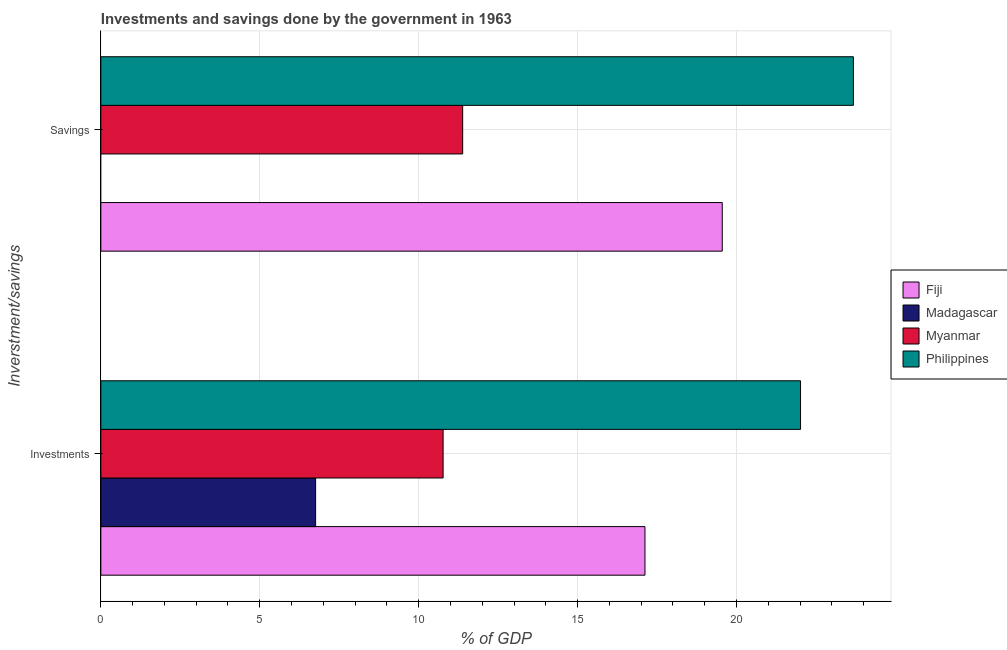How many different coloured bars are there?
Your response must be concise. 4. Are the number of bars on each tick of the Y-axis equal?
Provide a short and direct response. No. How many bars are there on the 2nd tick from the top?
Your answer should be very brief. 4. What is the label of the 2nd group of bars from the top?
Make the answer very short. Investments. What is the investments of government in Myanmar?
Offer a terse response. 10.77. Across all countries, what is the maximum investments of government?
Provide a short and direct response. 22.02. Across all countries, what is the minimum investments of government?
Your response must be concise. 6.76. What is the total investments of government in the graph?
Offer a very short reply. 56.66. What is the difference between the investments of government in Madagascar and that in Fiji?
Your answer should be very brief. -10.36. What is the difference between the savings of government in Madagascar and the investments of government in Philippines?
Offer a terse response. -22.02. What is the average investments of government per country?
Your answer should be very brief. 14.17. What is the difference between the investments of government and savings of government in Philippines?
Keep it short and to the point. -1.66. What is the ratio of the investments of government in Madagascar to that in Myanmar?
Keep it short and to the point. 0.63. Is the investments of government in Madagascar less than that in Myanmar?
Offer a very short reply. Yes. In how many countries, is the investments of government greater than the average investments of government taken over all countries?
Your response must be concise. 2. How many bars are there?
Offer a very short reply. 7. Are all the bars in the graph horizontal?
Ensure brevity in your answer.  Yes. How many countries are there in the graph?
Your response must be concise. 4. What is the difference between two consecutive major ticks on the X-axis?
Your answer should be very brief. 5. Does the graph contain grids?
Keep it short and to the point. Yes. Where does the legend appear in the graph?
Offer a terse response. Center right. How many legend labels are there?
Offer a terse response. 4. How are the legend labels stacked?
Keep it short and to the point. Vertical. What is the title of the graph?
Make the answer very short. Investments and savings done by the government in 1963. Does "Other small states" appear as one of the legend labels in the graph?
Keep it short and to the point. No. What is the label or title of the X-axis?
Ensure brevity in your answer.  % of GDP. What is the label or title of the Y-axis?
Your answer should be very brief. Inverstment/savings. What is the % of GDP of Fiji in Investments?
Keep it short and to the point. 17.12. What is the % of GDP in Madagascar in Investments?
Offer a very short reply. 6.76. What is the % of GDP of Myanmar in Investments?
Provide a short and direct response. 10.77. What is the % of GDP in Philippines in Investments?
Your answer should be very brief. 22.02. What is the % of GDP in Fiji in Savings?
Make the answer very short. 19.55. What is the % of GDP of Myanmar in Savings?
Your answer should be compact. 11.38. What is the % of GDP of Philippines in Savings?
Provide a succinct answer. 23.68. Across all Inverstment/savings, what is the maximum % of GDP in Fiji?
Offer a very short reply. 19.55. Across all Inverstment/savings, what is the maximum % of GDP in Madagascar?
Provide a succinct answer. 6.76. Across all Inverstment/savings, what is the maximum % of GDP of Myanmar?
Provide a short and direct response. 11.38. Across all Inverstment/savings, what is the maximum % of GDP in Philippines?
Your response must be concise. 23.68. Across all Inverstment/savings, what is the minimum % of GDP of Fiji?
Keep it short and to the point. 17.12. Across all Inverstment/savings, what is the minimum % of GDP in Myanmar?
Your answer should be very brief. 10.77. Across all Inverstment/savings, what is the minimum % of GDP of Philippines?
Offer a very short reply. 22.02. What is the total % of GDP of Fiji in the graph?
Your answer should be very brief. 36.67. What is the total % of GDP in Madagascar in the graph?
Provide a succinct answer. 6.76. What is the total % of GDP of Myanmar in the graph?
Ensure brevity in your answer.  22.15. What is the total % of GDP of Philippines in the graph?
Ensure brevity in your answer.  45.69. What is the difference between the % of GDP in Fiji in Investments and that in Savings?
Give a very brief answer. -2.43. What is the difference between the % of GDP in Myanmar in Investments and that in Savings?
Make the answer very short. -0.62. What is the difference between the % of GDP in Philippines in Investments and that in Savings?
Your response must be concise. -1.66. What is the difference between the % of GDP in Fiji in Investments and the % of GDP in Myanmar in Savings?
Provide a short and direct response. 5.74. What is the difference between the % of GDP in Fiji in Investments and the % of GDP in Philippines in Savings?
Give a very brief answer. -6.56. What is the difference between the % of GDP of Madagascar in Investments and the % of GDP of Myanmar in Savings?
Provide a short and direct response. -4.63. What is the difference between the % of GDP of Madagascar in Investments and the % of GDP of Philippines in Savings?
Your answer should be compact. -16.92. What is the difference between the % of GDP in Myanmar in Investments and the % of GDP in Philippines in Savings?
Your response must be concise. -12.91. What is the average % of GDP of Fiji per Inverstment/savings?
Offer a terse response. 18.34. What is the average % of GDP of Madagascar per Inverstment/savings?
Your answer should be compact. 3.38. What is the average % of GDP of Myanmar per Inverstment/savings?
Provide a short and direct response. 11.08. What is the average % of GDP of Philippines per Inverstment/savings?
Your answer should be very brief. 22.85. What is the difference between the % of GDP of Fiji and % of GDP of Madagascar in Investments?
Your answer should be very brief. 10.36. What is the difference between the % of GDP of Fiji and % of GDP of Myanmar in Investments?
Your answer should be compact. 6.35. What is the difference between the % of GDP in Fiji and % of GDP in Philippines in Investments?
Offer a terse response. -4.89. What is the difference between the % of GDP in Madagascar and % of GDP in Myanmar in Investments?
Ensure brevity in your answer.  -4.01. What is the difference between the % of GDP of Madagascar and % of GDP of Philippines in Investments?
Offer a terse response. -15.26. What is the difference between the % of GDP of Myanmar and % of GDP of Philippines in Investments?
Keep it short and to the point. -11.25. What is the difference between the % of GDP in Fiji and % of GDP in Myanmar in Savings?
Provide a succinct answer. 8.17. What is the difference between the % of GDP of Fiji and % of GDP of Philippines in Savings?
Offer a terse response. -4.13. What is the difference between the % of GDP in Myanmar and % of GDP in Philippines in Savings?
Ensure brevity in your answer.  -12.29. What is the ratio of the % of GDP in Fiji in Investments to that in Savings?
Your response must be concise. 0.88. What is the ratio of the % of GDP of Myanmar in Investments to that in Savings?
Your answer should be compact. 0.95. What is the ratio of the % of GDP of Philippines in Investments to that in Savings?
Your answer should be very brief. 0.93. What is the difference between the highest and the second highest % of GDP of Fiji?
Your answer should be very brief. 2.43. What is the difference between the highest and the second highest % of GDP in Myanmar?
Your answer should be compact. 0.62. What is the difference between the highest and the second highest % of GDP of Philippines?
Make the answer very short. 1.66. What is the difference between the highest and the lowest % of GDP of Fiji?
Offer a very short reply. 2.43. What is the difference between the highest and the lowest % of GDP of Madagascar?
Offer a very short reply. 6.76. What is the difference between the highest and the lowest % of GDP of Myanmar?
Ensure brevity in your answer.  0.62. What is the difference between the highest and the lowest % of GDP of Philippines?
Provide a short and direct response. 1.66. 